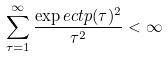Convert formula to latex. <formula><loc_0><loc_0><loc_500><loc_500>\sum _ { \tau = 1 } ^ { \infty } \frac { \exp e c t { p ( \tau ) ^ { 2 } } } { \tau ^ { 2 } } < \infty</formula> 